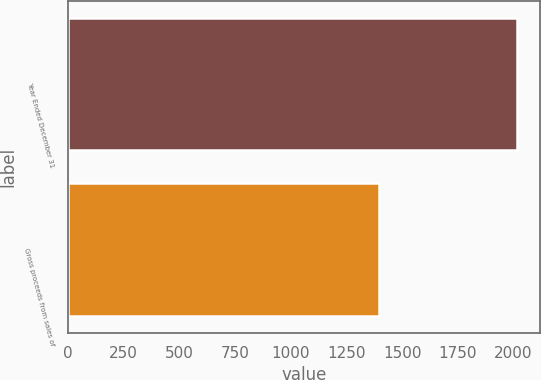Convert chart. <chart><loc_0><loc_0><loc_500><loc_500><bar_chart><fcel>Year Ended December 31<fcel>Gross proceeds from sales of<nl><fcel>2017<fcel>1398<nl></chart> 